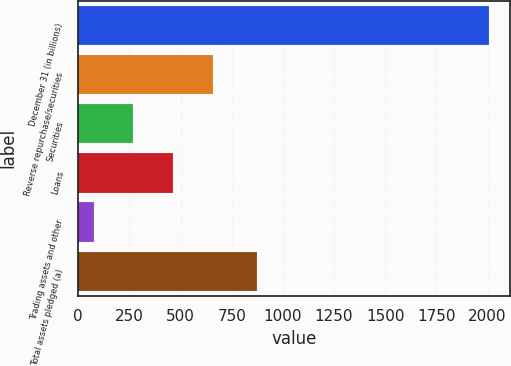Convert chart to OTSL. <chart><loc_0><loc_0><loc_500><loc_500><bar_chart><fcel>December 31 (in billions)<fcel>Reverse repurchase/securities<fcel>Securities<fcel>Loans<fcel>Trading assets and other<fcel>Total assets pledged (a)<nl><fcel>2009<fcel>656.46<fcel>270.02<fcel>463.24<fcel>76.8<fcel>874.3<nl></chart> 